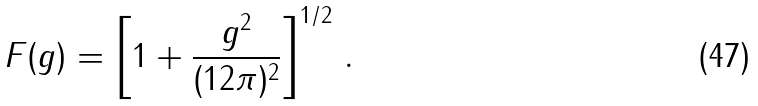<formula> <loc_0><loc_0><loc_500><loc_500>F ( g ) = \left [ 1 + \frac { g ^ { 2 } } { ( 1 2 \pi ) ^ { 2 } } \right ] ^ { 1 / 2 } \, .</formula> 